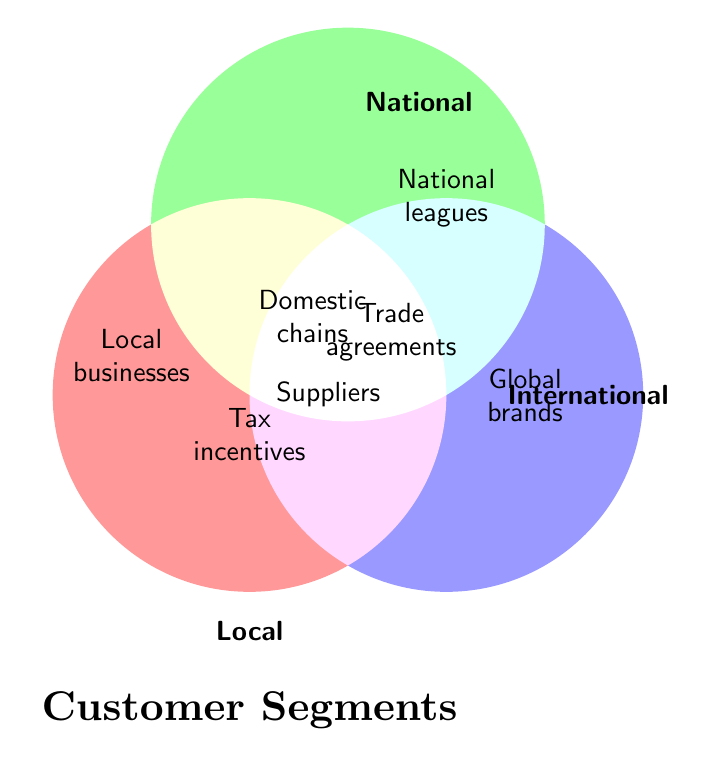Which customer segment is represented by red color? The red color segment is labeled as "Local."
Answer: Local Which segment is associated with multinational corporations? The segment for "multinational corporations" is represented by the "International" label in the figure.
Answer: International What is the title of the Venn Diagram? The title of the Venn Diagram is "Customer Segments."
Answer: Customer Segments Which segments overlap to form the "Trade agreements" category? The "Trade agreements" category is shown in the overlap between "National" and "International."
Answer: National and International Are "Domestic chains" more related to local or national segments? "Domestic chains" are labeled in the overlapping area between "Local" and "National" segments.
Answer: Both Local and National Which customer segment has city-specific promotions? City-specific promotions fall under the "Local" segment.
Answer: Local What is common between National and International segments but not found in the Local segment? "Trade agreements" represent a category common to both National and International segments but not Local.
Answer: Trade agreements Do international segments include community events? According to the Venn Diagram, community events are part of the Local segment, not International.
Answer: No Is "Suppliers" a shared attribute among all three customer segments? The "Suppliers" label is located at the intersection of all three segments (Local, National, and International).
Answer: Yes Which segment alone is associated with "Global brands"? "Global brands" are specifically placed in the International segment.
Answer: International 